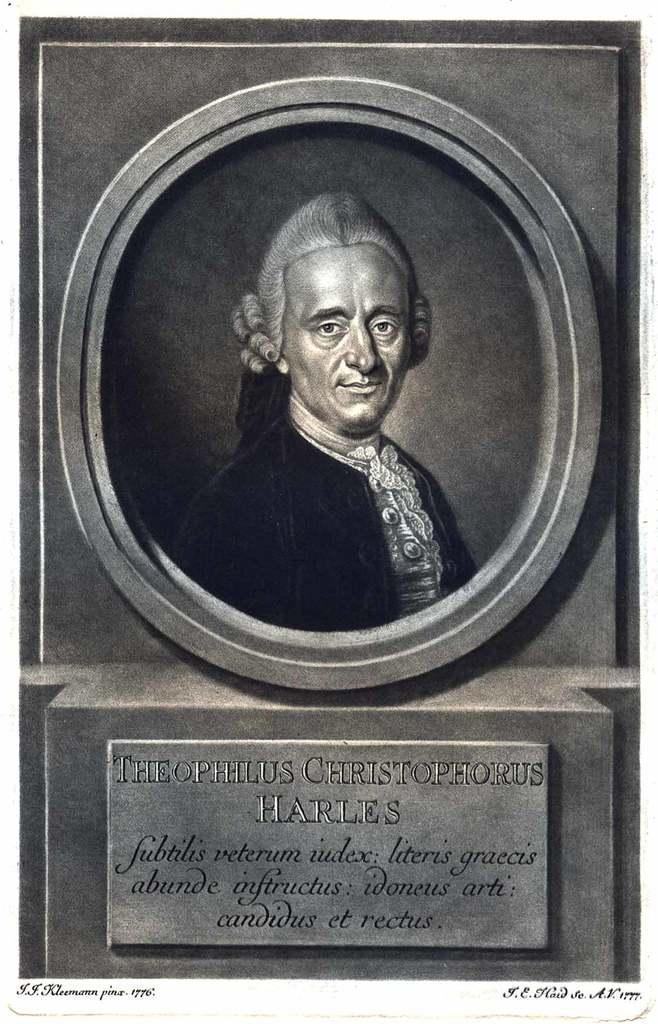In one or two sentences, can you explain what this image depicts? We can see statue on a wall and something written on a stone. At the bottom of the image we can see some text. 